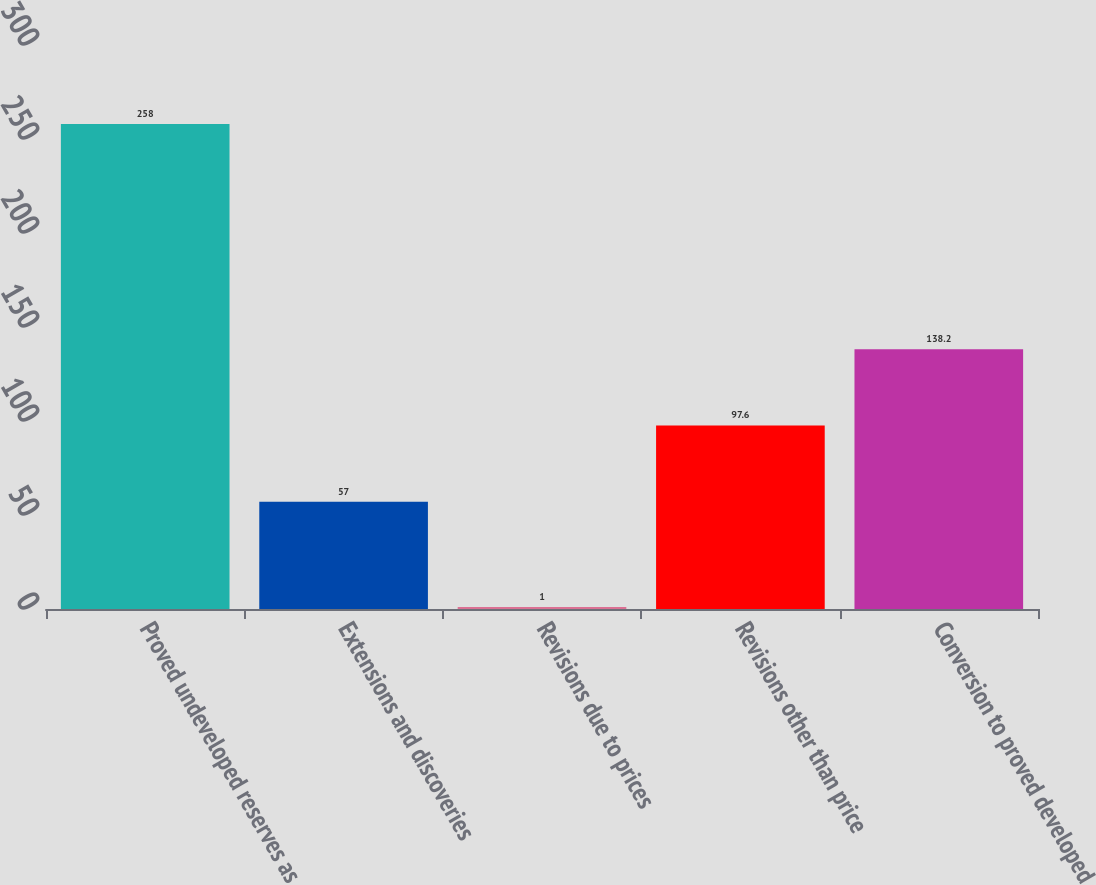Convert chart. <chart><loc_0><loc_0><loc_500><loc_500><bar_chart><fcel>Proved undeveloped reserves as<fcel>Extensions and discoveries<fcel>Revisions due to prices<fcel>Revisions other than price<fcel>Conversion to proved developed<nl><fcel>258<fcel>57<fcel>1<fcel>97.6<fcel>138.2<nl></chart> 